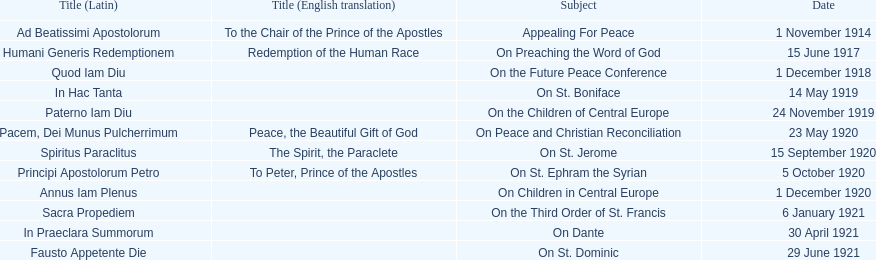What is the initial english translation mentioned in the chart? To the Chair of the Prince of the Apostles. 